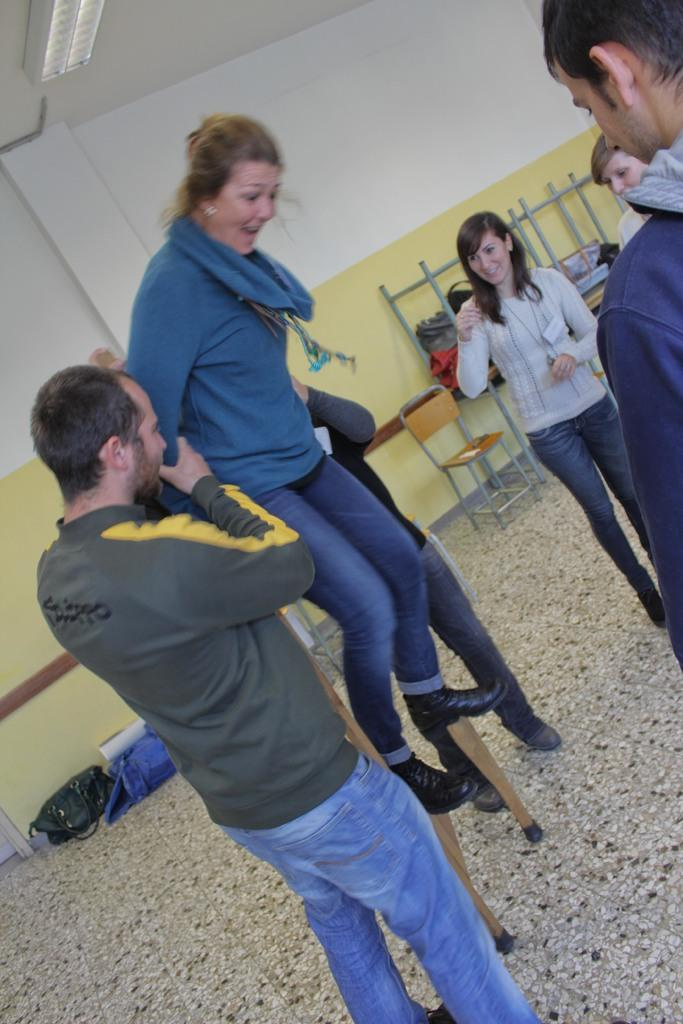What is the main subject of the image? The main subject of the image is a group of people. Can you describe the woman in the image? The woman is standing on sticks. What can be seen in the background of the image? There are chairs and a wall visible in the background of the image. Are there any objects present in the background? Yes, there are bags in the background of the image. What type of shoe is the woman wearing while standing on sticks in the image? There is no shoe visible in the image, as the woman is standing on sticks. 